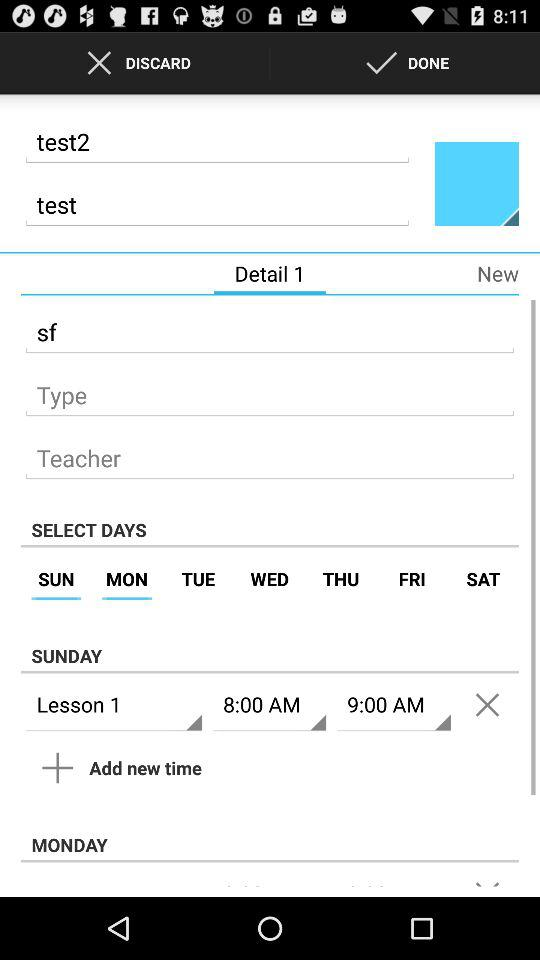Which tab is selected? The selected tab is "Detail 1". 